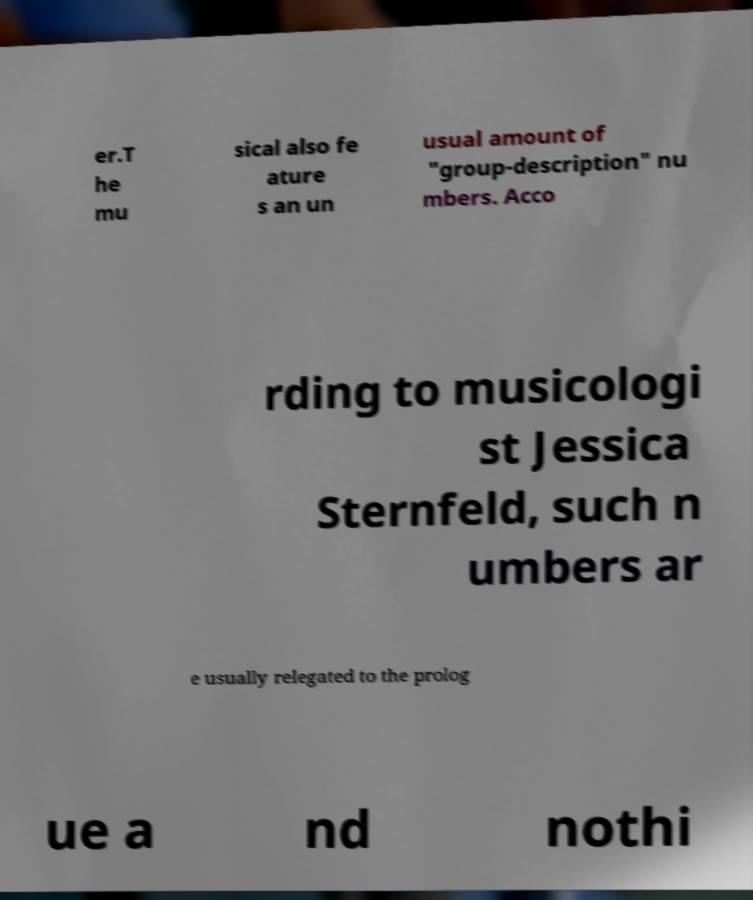What messages or text are displayed in this image? I need them in a readable, typed format. er.T he mu sical also fe ature s an un usual amount of "group-description" nu mbers. Acco rding to musicologi st Jessica Sternfeld, such n umbers ar e usually relegated to the prolog ue a nd nothi 